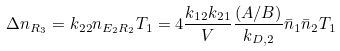<formula> <loc_0><loc_0><loc_500><loc_500>\Delta n _ { R _ { 3 } } = k _ { 2 2 } n _ { E _ { 2 } R _ { 2 } } T _ { 1 } = 4 \frac { k _ { 1 2 } k _ { 2 1 } } { V } \frac { ( A / B ) } { k _ { D , 2 } } \bar { n } _ { 1 } \bar { n } _ { 2 } T _ { 1 }</formula> 